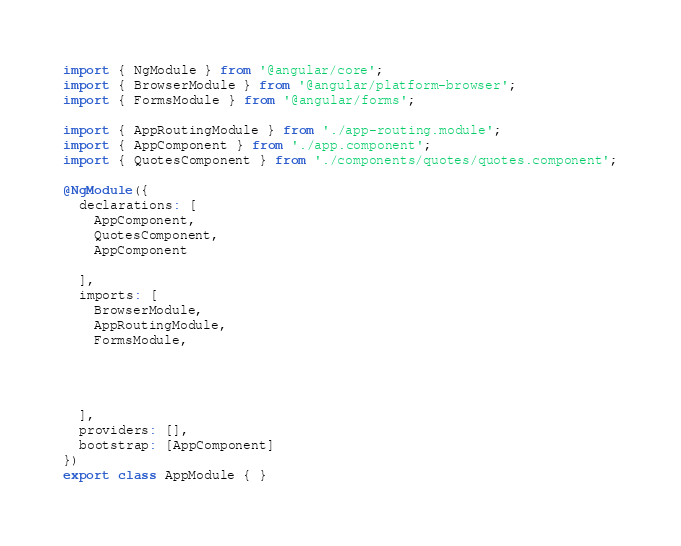Convert code to text. <code><loc_0><loc_0><loc_500><loc_500><_TypeScript_>import { NgModule } from '@angular/core';
import { BrowserModule } from '@angular/platform-browser';
import { FormsModule } from '@angular/forms';

import { AppRoutingModule } from './app-routing.module';
import { AppComponent } from './app.component';
import { QuotesComponent } from './components/quotes/quotes.component';

@NgModule({
  declarations: [
    AppComponent,
    QuotesComponent,
    AppComponent
    
  ],
  imports: [
    BrowserModule,
    AppRoutingModule,
    FormsModule,
  
    

    
  ],
  providers: [],
  bootstrap: [AppComponent]
})
export class AppModule { }
</code> 